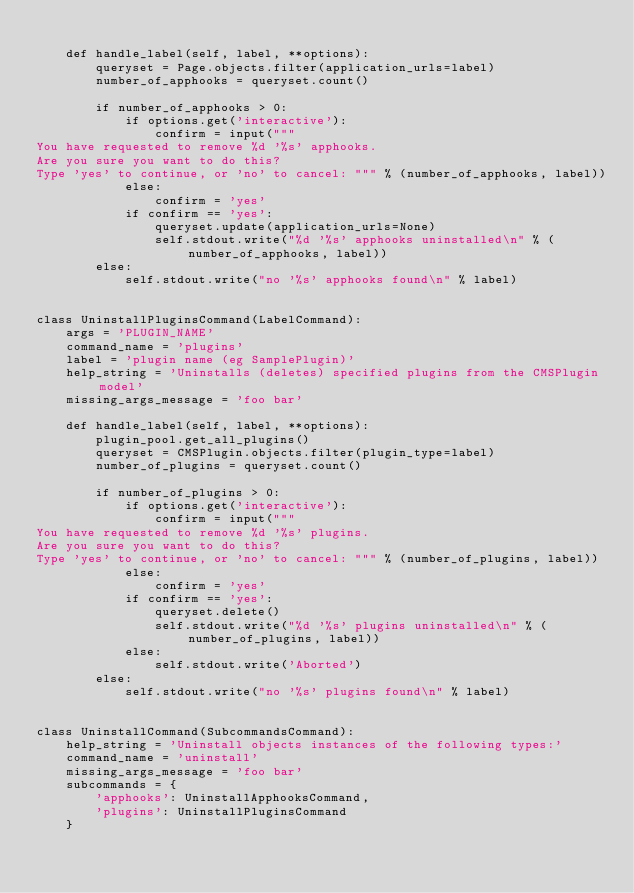<code> <loc_0><loc_0><loc_500><loc_500><_Python_>
    def handle_label(self, label, **options):
        queryset = Page.objects.filter(application_urls=label)
        number_of_apphooks = queryset.count()

        if number_of_apphooks > 0:
            if options.get('interactive'):
                confirm = input("""
You have requested to remove %d '%s' apphooks.
Are you sure you want to do this?
Type 'yes' to continue, or 'no' to cancel: """ % (number_of_apphooks, label))
            else:
                confirm = 'yes'
            if confirm == 'yes':
                queryset.update(application_urls=None)
                self.stdout.write("%d '%s' apphooks uninstalled\n" % (number_of_apphooks, label))
        else:
            self.stdout.write("no '%s' apphooks found\n" % label)


class UninstallPluginsCommand(LabelCommand):
    args = 'PLUGIN_NAME'
    command_name = 'plugins'
    label = 'plugin name (eg SamplePlugin)'
    help_string = 'Uninstalls (deletes) specified plugins from the CMSPlugin model'
    missing_args_message = 'foo bar'

    def handle_label(self, label, **options):
        plugin_pool.get_all_plugins()
        queryset = CMSPlugin.objects.filter(plugin_type=label)
        number_of_plugins = queryset.count()

        if number_of_plugins > 0:
            if options.get('interactive'):
                confirm = input("""
You have requested to remove %d '%s' plugins.
Are you sure you want to do this?
Type 'yes' to continue, or 'no' to cancel: """ % (number_of_plugins, label))
            else:
                confirm = 'yes'
            if confirm == 'yes':
                queryset.delete()
                self.stdout.write("%d '%s' plugins uninstalled\n" % (number_of_plugins, label))
            else:
                self.stdout.write('Aborted')
        else:
            self.stdout.write("no '%s' plugins found\n" % label)


class UninstallCommand(SubcommandsCommand):
    help_string = 'Uninstall objects instances of the following types:'
    command_name = 'uninstall'
    missing_args_message = 'foo bar'
    subcommands = {
        'apphooks': UninstallApphooksCommand,
        'plugins': UninstallPluginsCommand
    }
</code> 